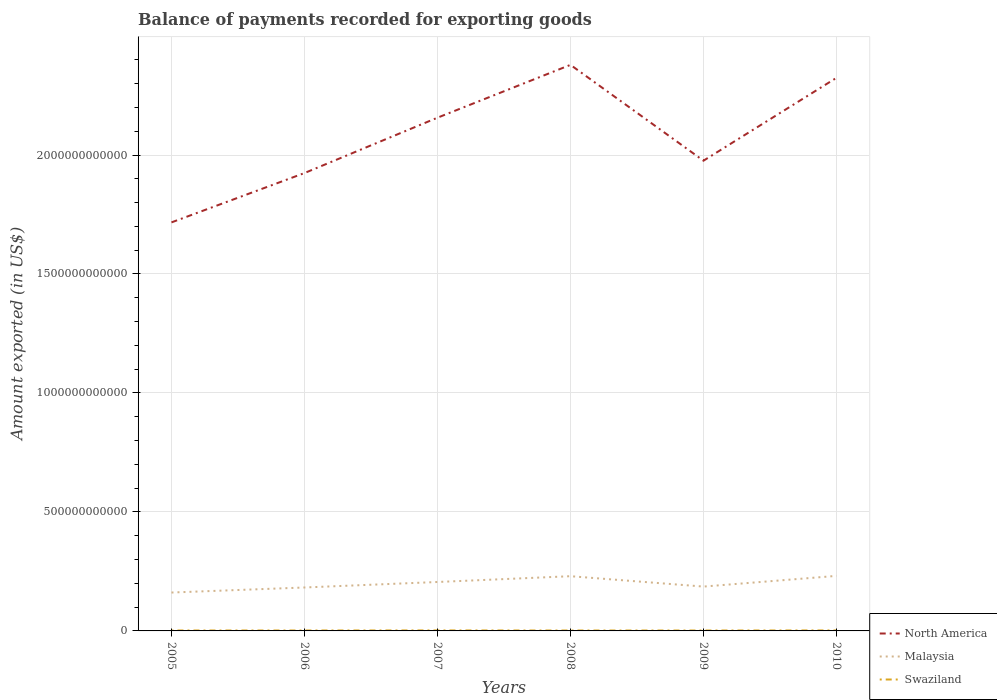How many different coloured lines are there?
Ensure brevity in your answer.  3. Does the line corresponding to North America intersect with the line corresponding to Malaysia?
Make the answer very short. No. Is the number of lines equal to the number of legend labels?
Your answer should be very brief. Yes. Across all years, what is the maximum amount exported in North America?
Your answer should be very brief. 1.72e+12. In which year was the amount exported in Malaysia maximum?
Provide a short and direct response. 2005. What is the total amount exported in North America in the graph?
Your answer should be very brief. -1.67e+11. What is the difference between the highest and the second highest amount exported in Swaziland?
Offer a very short reply. 3.75e+08. How many lines are there?
Provide a succinct answer. 3. How many years are there in the graph?
Keep it short and to the point. 6. What is the difference between two consecutive major ticks on the Y-axis?
Offer a very short reply. 5.00e+11. Are the values on the major ticks of Y-axis written in scientific E-notation?
Your answer should be very brief. No. Does the graph contain any zero values?
Ensure brevity in your answer.  No. Does the graph contain grids?
Give a very brief answer. Yes. How many legend labels are there?
Provide a short and direct response. 3. What is the title of the graph?
Your answer should be very brief. Balance of payments recorded for exporting goods. Does "Bolivia" appear as one of the legend labels in the graph?
Offer a very short reply. No. What is the label or title of the X-axis?
Ensure brevity in your answer.  Years. What is the label or title of the Y-axis?
Make the answer very short. Amount exported (in US$). What is the Amount exported (in US$) in North America in 2005?
Provide a short and direct response. 1.72e+12. What is the Amount exported (in US$) in Malaysia in 2005?
Offer a very short reply. 1.61e+11. What is the Amount exported (in US$) of Swaziland in 2005?
Ensure brevity in your answer.  1.80e+09. What is the Amount exported (in US$) of North America in 2006?
Offer a very short reply. 1.92e+12. What is the Amount exported (in US$) in Malaysia in 2006?
Give a very brief answer. 1.83e+11. What is the Amount exported (in US$) of Swaziland in 2006?
Ensure brevity in your answer.  1.84e+09. What is the Amount exported (in US$) of North America in 2007?
Offer a very short reply. 2.16e+12. What is the Amount exported (in US$) in Malaysia in 2007?
Your answer should be compact. 2.06e+11. What is the Amount exported (in US$) in Swaziland in 2007?
Provide a short and direct response. 2.12e+09. What is the Amount exported (in US$) in North America in 2008?
Your answer should be very brief. 2.38e+12. What is the Amount exported (in US$) of Malaysia in 2008?
Keep it short and to the point. 2.30e+11. What is the Amount exported (in US$) in Swaziland in 2008?
Make the answer very short. 1.74e+09. What is the Amount exported (in US$) in North America in 2009?
Your response must be concise. 1.98e+12. What is the Amount exported (in US$) in Malaysia in 2009?
Provide a short and direct response. 1.86e+11. What is the Amount exported (in US$) in Swaziland in 2009?
Offer a terse response. 1.78e+09. What is the Amount exported (in US$) of North America in 2010?
Your answer should be very brief. 2.32e+12. What is the Amount exported (in US$) in Malaysia in 2010?
Your answer should be compact. 2.31e+11. What is the Amount exported (in US$) in Swaziland in 2010?
Make the answer very short. 2.06e+09. Across all years, what is the maximum Amount exported (in US$) of North America?
Your answer should be very brief. 2.38e+12. Across all years, what is the maximum Amount exported (in US$) of Malaysia?
Provide a succinct answer. 2.31e+11. Across all years, what is the maximum Amount exported (in US$) in Swaziland?
Your answer should be very brief. 2.12e+09. Across all years, what is the minimum Amount exported (in US$) of North America?
Offer a very short reply. 1.72e+12. Across all years, what is the minimum Amount exported (in US$) in Malaysia?
Your answer should be very brief. 1.61e+11. Across all years, what is the minimum Amount exported (in US$) in Swaziland?
Make the answer very short. 1.74e+09. What is the total Amount exported (in US$) of North America in the graph?
Ensure brevity in your answer.  1.25e+13. What is the total Amount exported (in US$) in Malaysia in the graph?
Make the answer very short. 1.20e+12. What is the total Amount exported (in US$) in Swaziland in the graph?
Your answer should be very brief. 1.13e+1. What is the difference between the Amount exported (in US$) of North America in 2005 and that in 2006?
Make the answer very short. -2.07e+11. What is the difference between the Amount exported (in US$) in Malaysia in 2005 and that in 2006?
Ensure brevity in your answer.  -2.12e+1. What is the difference between the Amount exported (in US$) of Swaziland in 2005 and that in 2006?
Ensure brevity in your answer.  -3.32e+07. What is the difference between the Amount exported (in US$) of North America in 2005 and that in 2007?
Offer a very short reply. -4.40e+11. What is the difference between the Amount exported (in US$) of Malaysia in 2005 and that in 2007?
Provide a succinct answer. -4.43e+1. What is the difference between the Amount exported (in US$) of Swaziland in 2005 and that in 2007?
Your answer should be compact. -3.14e+08. What is the difference between the Amount exported (in US$) of North America in 2005 and that in 2008?
Make the answer very short. -6.62e+11. What is the difference between the Amount exported (in US$) of Malaysia in 2005 and that in 2008?
Provide a short and direct response. -6.86e+1. What is the difference between the Amount exported (in US$) of Swaziland in 2005 and that in 2008?
Your response must be concise. 6.04e+07. What is the difference between the Amount exported (in US$) of North America in 2005 and that in 2009?
Give a very brief answer. -2.59e+11. What is the difference between the Amount exported (in US$) of Malaysia in 2005 and that in 2009?
Your response must be concise. -2.50e+1. What is the difference between the Amount exported (in US$) in Swaziland in 2005 and that in 2009?
Provide a short and direct response. 2.92e+07. What is the difference between the Amount exported (in US$) of North America in 2005 and that in 2010?
Provide a short and direct response. -6.07e+11. What is the difference between the Amount exported (in US$) in Malaysia in 2005 and that in 2010?
Your response must be concise. -7.00e+1. What is the difference between the Amount exported (in US$) in Swaziland in 2005 and that in 2010?
Your answer should be very brief. -2.58e+08. What is the difference between the Amount exported (in US$) of North America in 2006 and that in 2007?
Ensure brevity in your answer.  -2.33e+11. What is the difference between the Amount exported (in US$) in Malaysia in 2006 and that in 2007?
Offer a very short reply. -2.31e+1. What is the difference between the Amount exported (in US$) of Swaziland in 2006 and that in 2007?
Offer a very short reply. -2.81e+08. What is the difference between the Amount exported (in US$) of North America in 2006 and that in 2008?
Your answer should be compact. -4.55e+11. What is the difference between the Amount exported (in US$) of Malaysia in 2006 and that in 2008?
Provide a short and direct response. -4.74e+1. What is the difference between the Amount exported (in US$) in Swaziland in 2006 and that in 2008?
Offer a terse response. 9.36e+07. What is the difference between the Amount exported (in US$) in North America in 2006 and that in 2009?
Your answer should be very brief. -5.20e+1. What is the difference between the Amount exported (in US$) of Malaysia in 2006 and that in 2009?
Offer a terse response. -3.78e+09. What is the difference between the Amount exported (in US$) in Swaziland in 2006 and that in 2009?
Ensure brevity in your answer.  6.24e+07. What is the difference between the Amount exported (in US$) in North America in 2006 and that in 2010?
Your response must be concise. -4.00e+11. What is the difference between the Amount exported (in US$) of Malaysia in 2006 and that in 2010?
Offer a very short reply. -4.87e+1. What is the difference between the Amount exported (in US$) of Swaziland in 2006 and that in 2010?
Your response must be concise. -2.25e+08. What is the difference between the Amount exported (in US$) in North America in 2007 and that in 2008?
Offer a very short reply. -2.22e+11. What is the difference between the Amount exported (in US$) in Malaysia in 2007 and that in 2008?
Provide a short and direct response. -2.44e+1. What is the difference between the Amount exported (in US$) of Swaziland in 2007 and that in 2008?
Make the answer very short. 3.75e+08. What is the difference between the Amount exported (in US$) of North America in 2007 and that in 2009?
Keep it short and to the point. 1.81e+11. What is the difference between the Amount exported (in US$) of Malaysia in 2007 and that in 2009?
Offer a terse response. 1.93e+1. What is the difference between the Amount exported (in US$) in Swaziland in 2007 and that in 2009?
Offer a terse response. 3.43e+08. What is the difference between the Amount exported (in US$) in North America in 2007 and that in 2010?
Give a very brief answer. -1.67e+11. What is the difference between the Amount exported (in US$) of Malaysia in 2007 and that in 2010?
Keep it short and to the point. -2.57e+1. What is the difference between the Amount exported (in US$) in Swaziland in 2007 and that in 2010?
Give a very brief answer. 5.61e+07. What is the difference between the Amount exported (in US$) of North America in 2008 and that in 2009?
Keep it short and to the point. 4.03e+11. What is the difference between the Amount exported (in US$) in Malaysia in 2008 and that in 2009?
Offer a terse response. 4.36e+1. What is the difference between the Amount exported (in US$) in Swaziland in 2008 and that in 2009?
Your answer should be compact. -3.12e+07. What is the difference between the Amount exported (in US$) of North America in 2008 and that in 2010?
Keep it short and to the point. 5.46e+1. What is the difference between the Amount exported (in US$) in Malaysia in 2008 and that in 2010?
Your answer should be compact. -1.34e+09. What is the difference between the Amount exported (in US$) in Swaziland in 2008 and that in 2010?
Provide a short and direct response. -3.19e+08. What is the difference between the Amount exported (in US$) in North America in 2009 and that in 2010?
Offer a very short reply. -3.48e+11. What is the difference between the Amount exported (in US$) in Malaysia in 2009 and that in 2010?
Provide a succinct answer. -4.50e+1. What is the difference between the Amount exported (in US$) in Swaziland in 2009 and that in 2010?
Keep it short and to the point. -2.87e+08. What is the difference between the Amount exported (in US$) in North America in 2005 and the Amount exported (in US$) in Malaysia in 2006?
Provide a succinct answer. 1.53e+12. What is the difference between the Amount exported (in US$) in North America in 2005 and the Amount exported (in US$) in Swaziland in 2006?
Make the answer very short. 1.71e+12. What is the difference between the Amount exported (in US$) in Malaysia in 2005 and the Amount exported (in US$) in Swaziland in 2006?
Your answer should be compact. 1.60e+11. What is the difference between the Amount exported (in US$) in North America in 2005 and the Amount exported (in US$) in Malaysia in 2007?
Provide a succinct answer. 1.51e+12. What is the difference between the Amount exported (in US$) in North America in 2005 and the Amount exported (in US$) in Swaziland in 2007?
Offer a terse response. 1.71e+12. What is the difference between the Amount exported (in US$) in Malaysia in 2005 and the Amount exported (in US$) in Swaziland in 2007?
Provide a succinct answer. 1.59e+11. What is the difference between the Amount exported (in US$) of North America in 2005 and the Amount exported (in US$) of Malaysia in 2008?
Provide a succinct answer. 1.49e+12. What is the difference between the Amount exported (in US$) in North America in 2005 and the Amount exported (in US$) in Swaziland in 2008?
Your response must be concise. 1.72e+12. What is the difference between the Amount exported (in US$) in Malaysia in 2005 and the Amount exported (in US$) in Swaziland in 2008?
Your answer should be compact. 1.60e+11. What is the difference between the Amount exported (in US$) of North America in 2005 and the Amount exported (in US$) of Malaysia in 2009?
Your response must be concise. 1.53e+12. What is the difference between the Amount exported (in US$) of North America in 2005 and the Amount exported (in US$) of Swaziland in 2009?
Your answer should be compact. 1.72e+12. What is the difference between the Amount exported (in US$) in Malaysia in 2005 and the Amount exported (in US$) in Swaziland in 2009?
Make the answer very short. 1.60e+11. What is the difference between the Amount exported (in US$) of North America in 2005 and the Amount exported (in US$) of Malaysia in 2010?
Offer a very short reply. 1.49e+12. What is the difference between the Amount exported (in US$) of North America in 2005 and the Amount exported (in US$) of Swaziland in 2010?
Your response must be concise. 1.71e+12. What is the difference between the Amount exported (in US$) in Malaysia in 2005 and the Amount exported (in US$) in Swaziland in 2010?
Your answer should be compact. 1.59e+11. What is the difference between the Amount exported (in US$) of North America in 2006 and the Amount exported (in US$) of Malaysia in 2007?
Ensure brevity in your answer.  1.72e+12. What is the difference between the Amount exported (in US$) of North America in 2006 and the Amount exported (in US$) of Swaziland in 2007?
Make the answer very short. 1.92e+12. What is the difference between the Amount exported (in US$) of Malaysia in 2006 and the Amount exported (in US$) of Swaziland in 2007?
Give a very brief answer. 1.80e+11. What is the difference between the Amount exported (in US$) of North America in 2006 and the Amount exported (in US$) of Malaysia in 2008?
Provide a short and direct response. 1.69e+12. What is the difference between the Amount exported (in US$) in North America in 2006 and the Amount exported (in US$) in Swaziland in 2008?
Provide a succinct answer. 1.92e+12. What is the difference between the Amount exported (in US$) in Malaysia in 2006 and the Amount exported (in US$) in Swaziland in 2008?
Offer a terse response. 1.81e+11. What is the difference between the Amount exported (in US$) of North America in 2006 and the Amount exported (in US$) of Malaysia in 2009?
Your response must be concise. 1.74e+12. What is the difference between the Amount exported (in US$) of North America in 2006 and the Amount exported (in US$) of Swaziland in 2009?
Ensure brevity in your answer.  1.92e+12. What is the difference between the Amount exported (in US$) of Malaysia in 2006 and the Amount exported (in US$) of Swaziland in 2009?
Your response must be concise. 1.81e+11. What is the difference between the Amount exported (in US$) of North America in 2006 and the Amount exported (in US$) of Malaysia in 2010?
Give a very brief answer. 1.69e+12. What is the difference between the Amount exported (in US$) of North America in 2006 and the Amount exported (in US$) of Swaziland in 2010?
Make the answer very short. 1.92e+12. What is the difference between the Amount exported (in US$) of Malaysia in 2006 and the Amount exported (in US$) of Swaziland in 2010?
Your response must be concise. 1.81e+11. What is the difference between the Amount exported (in US$) of North America in 2007 and the Amount exported (in US$) of Malaysia in 2008?
Offer a very short reply. 1.93e+12. What is the difference between the Amount exported (in US$) in North America in 2007 and the Amount exported (in US$) in Swaziland in 2008?
Give a very brief answer. 2.16e+12. What is the difference between the Amount exported (in US$) of Malaysia in 2007 and the Amount exported (in US$) of Swaziland in 2008?
Your response must be concise. 2.04e+11. What is the difference between the Amount exported (in US$) in North America in 2007 and the Amount exported (in US$) in Malaysia in 2009?
Give a very brief answer. 1.97e+12. What is the difference between the Amount exported (in US$) in North America in 2007 and the Amount exported (in US$) in Swaziland in 2009?
Provide a succinct answer. 2.16e+12. What is the difference between the Amount exported (in US$) in Malaysia in 2007 and the Amount exported (in US$) in Swaziland in 2009?
Your answer should be compact. 2.04e+11. What is the difference between the Amount exported (in US$) in North America in 2007 and the Amount exported (in US$) in Malaysia in 2010?
Keep it short and to the point. 1.93e+12. What is the difference between the Amount exported (in US$) of North America in 2007 and the Amount exported (in US$) of Swaziland in 2010?
Make the answer very short. 2.15e+12. What is the difference between the Amount exported (in US$) in Malaysia in 2007 and the Amount exported (in US$) in Swaziland in 2010?
Give a very brief answer. 2.04e+11. What is the difference between the Amount exported (in US$) of North America in 2008 and the Amount exported (in US$) of Malaysia in 2009?
Your answer should be compact. 2.19e+12. What is the difference between the Amount exported (in US$) in North America in 2008 and the Amount exported (in US$) in Swaziland in 2009?
Provide a succinct answer. 2.38e+12. What is the difference between the Amount exported (in US$) of Malaysia in 2008 and the Amount exported (in US$) of Swaziland in 2009?
Provide a short and direct response. 2.28e+11. What is the difference between the Amount exported (in US$) of North America in 2008 and the Amount exported (in US$) of Malaysia in 2010?
Make the answer very short. 2.15e+12. What is the difference between the Amount exported (in US$) in North America in 2008 and the Amount exported (in US$) in Swaziland in 2010?
Offer a terse response. 2.38e+12. What is the difference between the Amount exported (in US$) of Malaysia in 2008 and the Amount exported (in US$) of Swaziland in 2010?
Your response must be concise. 2.28e+11. What is the difference between the Amount exported (in US$) in North America in 2009 and the Amount exported (in US$) in Malaysia in 2010?
Give a very brief answer. 1.74e+12. What is the difference between the Amount exported (in US$) in North America in 2009 and the Amount exported (in US$) in Swaziland in 2010?
Offer a terse response. 1.97e+12. What is the difference between the Amount exported (in US$) in Malaysia in 2009 and the Amount exported (in US$) in Swaziland in 2010?
Make the answer very short. 1.84e+11. What is the average Amount exported (in US$) in North America per year?
Give a very brief answer. 2.08e+12. What is the average Amount exported (in US$) in Malaysia per year?
Provide a succinct answer. 2.00e+11. What is the average Amount exported (in US$) of Swaziland per year?
Ensure brevity in your answer.  1.89e+09. In the year 2005, what is the difference between the Amount exported (in US$) in North America and Amount exported (in US$) in Malaysia?
Make the answer very short. 1.56e+12. In the year 2005, what is the difference between the Amount exported (in US$) in North America and Amount exported (in US$) in Swaziland?
Make the answer very short. 1.72e+12. In the year 2005, what is the difference between the Amount exported (in US$) in Malaysia and Amount exported (in US$) in Swaziland?
Your response must be concise. 1.60e+11. In the year 2006, what is the difference between the Amount exported (in US$) of North America and Amount exported (in US$) of Malaysia?
Your answer should be very brief. 1.74e+12. In the year 2006, what is the difference between the Amount exported (in US$) of North America and Amount exported (in US$) of Swaziland?
Offer a terse response. 1.92e+12. In the year 2006, what is the difference between the Amount exported (in US$) in Malaysia and Amount exported (in US$) in Swaziland?
Make the answer very short. 1.81e+11. In the year 2007, what is the difference between the Amount exported (in US$) in North America and Amount exported (in US$) in Malaysia?
Your response must be concise. 1.95e+12. In the year 2007, what is the difference between the Amount exported (in US$) of North America and Amount exported (in US$) of Swaziland?
Make the answer very short. 2.15e+12. In the year 2007, what is the difference between the Amount exported (in US$) of Malaysia and Amount exported (in US$) of Swaziland?
Provide a short and direct response. 2.04e+11. In the year 2008, what is the difference between the Amount exported (in US$) of North America and Amount exported (in US$) of Malaysia?
Your answer should be compact. 2.15e+12. In the year 2008, what is the difference between the Amount exported (in US$) of North America and Amount exported (in US$) of Swaziland?
Your answer should be compact. 2.38e+12. In the year 2008, what is the difference between the Amount exported (in US$) of Malaysia and Amount exported (in US$) of Swaziland?
Provide a succinct answer. 2.28e+11. In the year 2009, what is the difference between the Amount exported (in US$) in North America and Amount exported (in US$) in Malaysia?
Your answer should be very brief. 1.79e+12. In the year 2009, what is the difference between the Amount exported (in US$) in North America and Amount exported (in US$) in Swaziland?
Ensure brevity in your answer.  1.97e+12. In the year 2009, what is the difference between the Amount exported (in US$) of Malaysia and Amount exported (in US$) of Swaziland?
Ensure brevity in your answer.  1.85e+11. In the year 2010, what is the difference between the Amount exported (in US$) of North America and Amount exported (in US$) of Malaysia?
Give a very brief answer. 2.09e+12. In the year 2010, what is the difference between the Amount exported (in US$) of North America and Amount exported (in US$) of Swaziland?
Offer a terse response. 2.32e+12. In the year 2010, what is the difference between the Amount exported (in US$) of Malaysia and Amount exported (in US$) of Swaziland?
Provide a succinct answer. 2.29e+11. What is the ratio of the Amount exported (in US$) of North America in 2005 to that in 2006?
Provide a short and direct response. 0.89. What is the ratio of the Amount exported (in US$) in Malaysia in 2005 to that in 2006?
Make the answer very short. 0.88. What is the ratio of the Amount exported (in US$) in Swaziland in 2005 to that in 2006?
Provide a succinct answer. 0.98. What is the ratio of the Amount exported (in US$) in North America in 2005 to that in 2007?
Ensure brevity in your answer.  0.8. What is the ratio of the Amount exported (in US$) in Malaysia in 2005 to that in 2007?
Offer a very short reply. 0.78. What is the ratio of the Amount exported (in US$) in Swaziland in 2005 to that in 2007?
Keep it short and to the point. 0.85. What is the ratio of the Amount exported (in US$) of North America in 2005 to that in 2008?
Provide a short and direct response. 0.72. What is the ratio of the Amount exported (in US$) in Malaysia in 2005 to that in 2008?
Provide a succinct answer. 0.7. What is the ratio of the Amount exported (in US$) in Swaziland in 2005 to that in 2008?
Give a very brief answer. 1.03. What is the ratio of the Amount exported (in US$) in North America in 2005 to that in 2009?
Give a very brief answer. 0.87. What is the ratio of the Amount exported (in US$) in Malaysia in 2005 to that in 2009?
Provide a short and direct response. 0.87. What is the ratio of the Amount exported (in US$) in Swaziland in 2005 to that in 2009?
Provide a succinct answer. 1.02. What is the ratio of the Amount exported (in US$) in North America in 2005 to that in 2010?
Give a very brief answer. 0.74. What is the ratio of the Amount exported (in US$) in Malaysia in 2005 to that in 2010?
Provide a succinct answer. 0.7. What is the ratio of the Amount exported (in US$) of Swaziland in 2005 to that in 2010?
Give a very brief answer. 0.87. What is the ratio of the Amount exported (in US$) in North America in 2006 to that in 2007?
Offer a terse response. 0.89. What is the ratio of the Amount exported (in US$) in Malaysia in 2006 to that in 2007?
Provide a short and direct response. 0.89. What is the ratio of the Amount exported (in US$) of Swaziland in 2006 to that in 2007?
Offer a terse response. 0.87. What is the ratio of the Amount exported (in US$) of North America in 2006 to that in 2008?
Your answer should be very brief. 0.81. What is the ratio of the Amount exported (in US$) of Malaysia in 2006 to that in 2008?
Provide a short and direct response. 0.79. What is the ratio of the Amount exported (in US$) in Swaziland in 2006 to that in 2008?
Your answer should be compact. 1.05. What is the ratio of the Amount exported (in US$) in North America in 2006 to that in 2009?
Make the answer very short. 0.97. What is the ratio of the Amount exported (in US$) of Malaysia in 2006 to that in 2009?
Your answer should be very brief. 0.98. What is the ratio of the Amount exported (in US$) of Swaziland in 2006 to that in 2009?
Offer a very short reply. 1.04. What is the ratio of the Amount exported (in US$) of North America in 2006 to that in 2010?
Your answer should be compact. 0.83. What is the ratio of the Amount exported (in US$) in Malaysia in 2006 to that in 2010?
Offer a very short reply. 0.79. What is the ratio of the Amount exported (in US$) in Swaziland in 2006 to that in 2010?
Your answer should be very brief. 0.89. What is the ratio of the Amount exported (in US$) of North America in 2007 to that in 2008?
Your response must be concise. 0.91. What is the ratio of the Amount exported (in US$) in Malaysia in 2007 to that in 2008?
Provide a short and direct response. 0.89. What is the ratio of the Amount exported (in US$) of Swaziland in 2007 to that in 2008?
Your answer should be very brief. 1.21. What is the ratio of the Amount exported (in US$) in North America in 2007 to that in 2009?
Keep it short and to the point. 1.09. What is the ratio of the Amount exported (in US$) in Malaysia in 2007 to that in 2009?
Your response must be concise. 1.1. What is the ratio of the Amount exported (in US$) in Swaziland in 2007 to that in 2009?
Your answer should be compact. 1.19. What is the ratio of the Amount exported (in US$) of North America in 2007 to that in 2010?
Provide a succinct answer. 0.93. What is the ratio of the Amount exported (in US$) in Malaysia in 2007 to that in 2010?
Give a very brief answer. 0.89. What is the ratio of the Amount exported (in US$) in Swaziland in 2007 to that in 2010?
Provide a succinct answer. 1.03. What is the ratio of the Amount exported (in US$) in North America in 2008 to that in 2009?
Your answer should be very brief. 1.2. What is the ratio of the Amount exported (in US$) of Malaysia in 2008 to that in 2009?
Ensure brevity in your answer.  1.23. What is the ratio of the Amount exported (in US$) in Swaziland in 2008 to that in 2009?
Offer a very short reply. 0.98. What is the ratio of the Amount exported (in US$) in North America in 2008 to that in 2010?
Offer a terse response. 1.02. What is the ratio of the Amount exported (in US$) of Swaziland in 2008 to that in 2010?
Your response must be concise. 0.85. What is the ratio of the Amount exported (in US$) in North America in 2009 to that in 2010?
Ensure brevity in your answer.  0.85. What is the ratio of the Amount exported (in US$) in Malaysia in 2009 to that in 2010?
Your answer should be very brief. 0.81. What is the ratio of the Amount exported (in US$) in Swaziland in 2009 to that in 2010?
Ensure brevity in your answer.  0.86. What is the difference between the highest and the second highest Amount exported (in US$) of North America?
Keep it short and to the point. 5.46e+1. What is the difference between the highest and the second highest Amount exported (in US$) in Malaysia?
Provide a succinct answer. 1.34e+09. What is the difference between the highest and the second highest Amount exported (in US$) of Swaziland?
Your response must be concise. 5.61e+07. What is the difference between the highest and the lowest Amount exported (in US$) of North America?
Provide a short and direct response. 6.62e+11. What is the difference between the highest and the lowest Amount exported (in US$) in Malaysia?
Ensure brevity in your answer.  7.00e+1. What is the difference between the highest and the lowest Amount exported (in US$) in Swaziland?
Keep it short and to the point. 3.75e+08. 